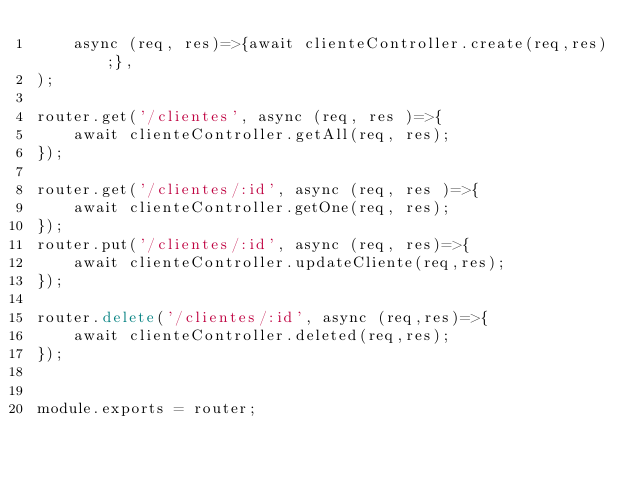Convert code to text. <code><loc_0><loc_0><loc_500><loc_500><_JavaScript_>    async (req, res)=>{await clienteController.create(req,res);},
);

router.get('/clientes', async (req, res )=>{
    await clienteController.getAll(req, res);
});

router.get('/clientes/:id', async (req, res )=>{
    await clienteController.getOne(req, res);
});
router.put('/clientes/:id', async (req, res)=>{
    await clienteController.updateCliente(req,res);
});

router.delete('/clientes/:id', async (req,res)=>{
    await clienteController.deleted(req,res);
});


module.exports = router;</code> 